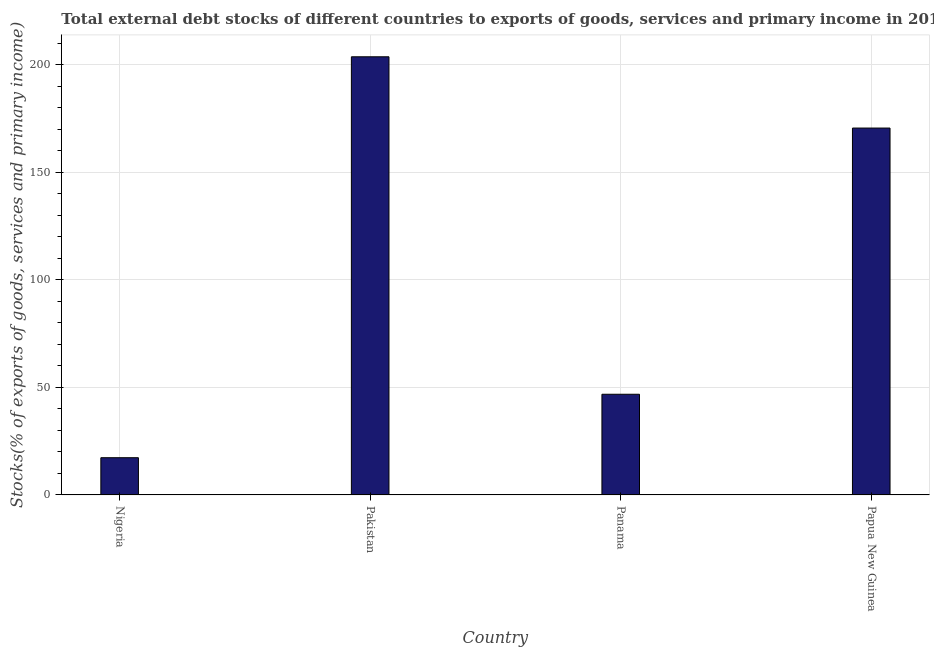Does the graph contain grids?
Your answer should be very brief. Yes. What is the title of the graph?
Keep it short and to the point. Total external debt stocks of different countries to exports of goods, services and primary income in 2011. What is the label or title of the Y-axis?
Your answer should be very brief. Stocks(% of exports of goods, services and primary income). What is the external debt stocks in Pakistan?
Offer a terse response. 203.65. Across all countries, what is the maximum external debt stocks?
Your answer should be very brief. 203.65. Across all countries, what is the minimum external debt stocks?
Give a very brief answer. 17.3. In which country was the external debt stocks minimum?
Your response must be concise. Nigeria. What is the sum of the external debt stocks?
Offer a terse response. 438.27. What is the difference between the external debt stocks in Pakistan and Panama?
Keep it short and to the point. 156.85. What is the average external debt stocks per country?
Make the answer very short. 109.57. What is the median external debt stocks?
Your answer should be compact. 108.66. What is the ratio of the external debt stocks in Nigeria to that in Pakistan?
Your response must be concise. 0.09. What is the difference between the highest and the second highest external debt stocks?
Offer a very short reply. 33.12. What is the difference between the highest and the lowest external debt stocks?
Keep it short and to the point. 186.35. What is the difference between two consecutive major ticks on the Y-axis?
Your answer should be very brief. 50. What is the Stocks(% of exports of goods, services and primary income) in Nigeria?
Your answer should be very brief. 17.3. What is the Stocks(% of exports of goods, services and primary income) of Pakistan?
Offer a very short reply. 203.65. What is the Stocks(% of exports of goods, services and primary income) of Panama?
Give a very brief answer. 46.8. What is the Stocks(% of exports of goods, services and primary income) of Papua New Guinea?
Provide a succinct answer. 170.52. What is the difference between the Stocks(% of exports of goods, services and primary income) in Nigeria and Pakistan?
Your response must be concise. -186.35. What is the difference between the Stocks(% of exports of goods, services and primary income) in Nigeria and Panama?
Offer a terse response. -29.49. What is the difference between the Stocks(% of exports of goods, services and primary income) in Nigeria and Papua New Guinea?
Make the answer very short. -153.22. What is the difference between the Stocks(% of exports of goods, services and primary income) in Pakistan and Panama?
Offer a terse response. 156.85. What is the difference between the Stocks(% of exports of goods, services and primary income) in Pakistan and Papua New Guinea?
Offer a very short reply. 33.12. What is the difference between the Stocks(% of exports of goods, services and primary income) in Panama and Papua New Guinea?
Your response must be concise. -123.73. What is the ratio of the Stocks(% of exports of goods, services and primary income) in Nigeria to that in Pakistan?
Keep it short and to the point. 0.09. What is the ratio of the Stocks(% of exports of goods, services and primary income) in Nigeria to that in Panama?
Give a very brief answer. 0.37. What is the ratio of the Stocks(% of exports of goods, services and primary income) in Nigeria to that in Papua New Guinea?
Keep it short and to the point. 0.1. What is the ratio of the Stocks(% of exports of goods, services and primary income) in Pakistan to that in Panama?
Your answer should be very brief. 4.35. What is the ratio of the Stocks(% of exports of goods, services and primary income) in Pakistan to that in Papua New Guinea?
Offer a very short reply. 1.19. What is the ratio of the Stocks(% of exports of goods, services and primary income) in Panama to that in Papua New Guinea?
Your response must be concise. 0.27. 